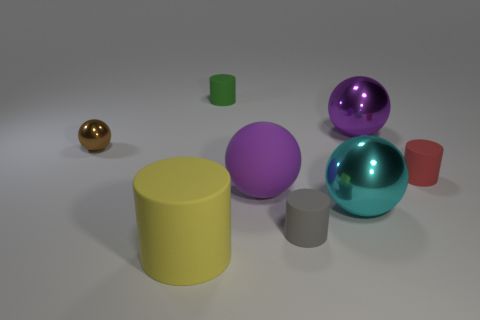Subtract 1 balls. How many balls are left? 3 Add 2 brown metal balls. How many objects exist? 10 Subtract 0 brown cylinders. How many objects are left? 8 Subtract all cyan spheres. Subtract all shiny things. How many objects are left? 4 Add 3 tiny gray rubber things. How many tiny gray rubber things are left? 4 Add 4 big cyan things. How many big cyan things exist? 5 